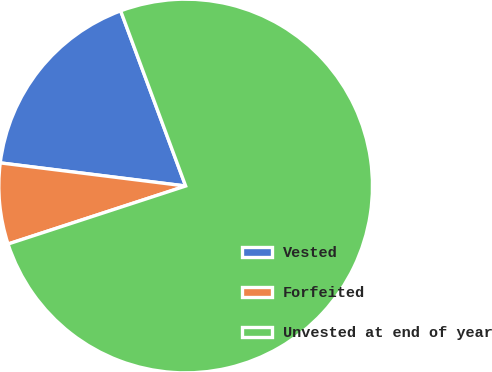<chart> <loc_0><loc_0><loc_500><loc_500><pie_chart><fcel>Vested<fcel>Forfeited<fcel>Unvested at end of year<nl><fcel>17.37%<fcel>7.0%<fcel>75.63%<nl></chart> 